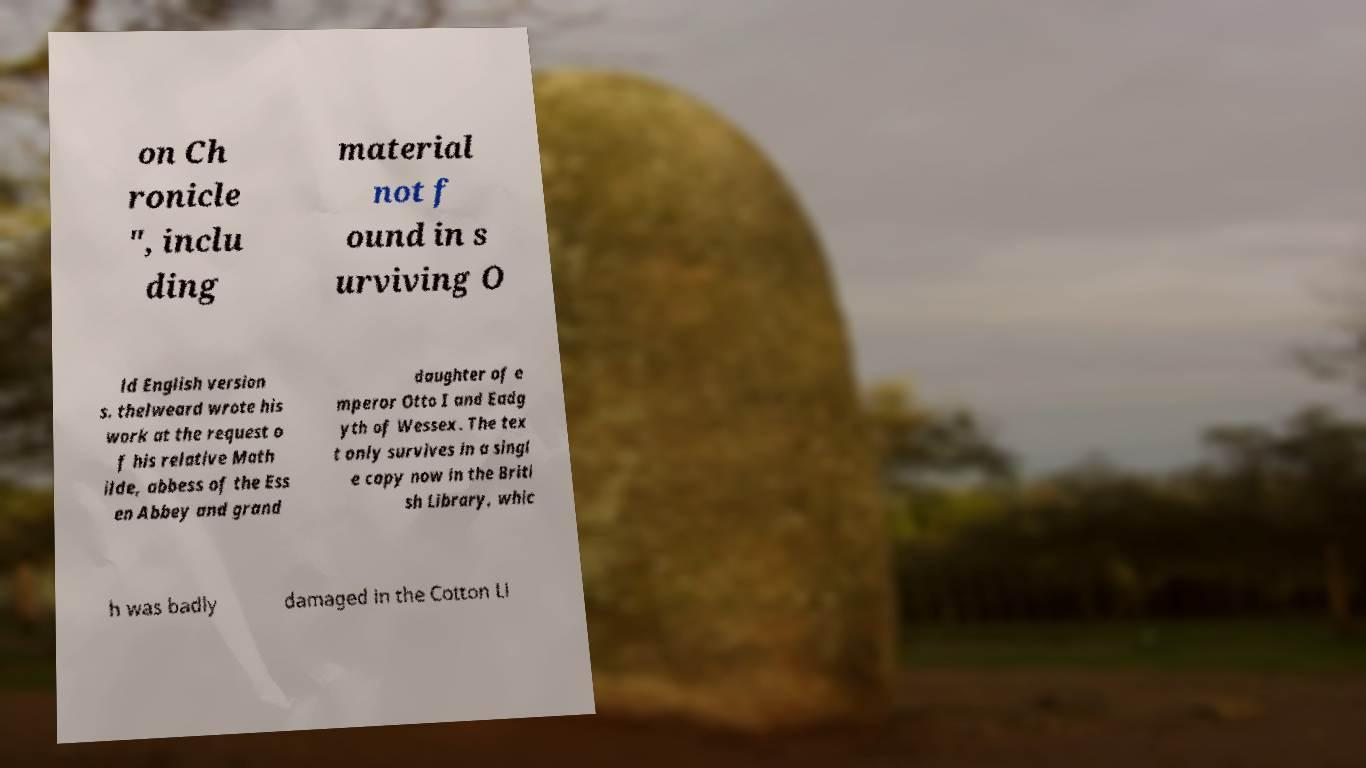Could you extract and type out the text from this image? on Ch ronicle ", inclu ding material not f ound in s urviving O ld English version s. thelweard wrote his work at the request o f his relative Math ilde, abbess of the Ess en Abbey and grand daughter of e mperor Otto I and Eadg yth of Wessex. The tex t only survives in a singl e copy now in the Briti sh Library, whic h was badly damaged in the Cotton Li 